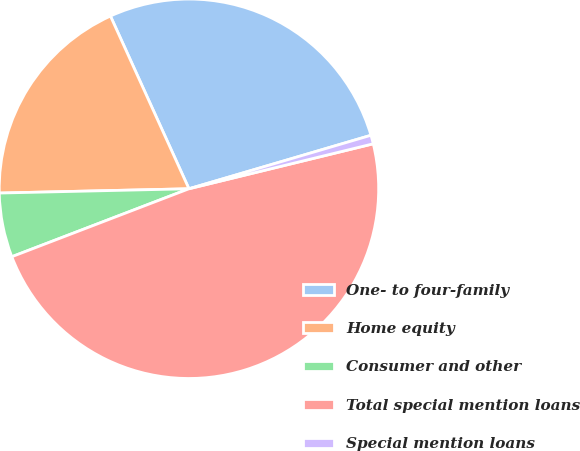Convert chart to OTSL. <chart><loc_0><loc_0><loc_500><loc_500><pie_chart><fcel>One- to four-family<fcel>Home equity<fcel>Consumer and other<fcel>Total special mention loans<fcel>Special mention loans<nl><fcel>27.24%<fcel>18.57%<fcel>5.47%<fcel>47.98%<fcel>0.74%<nl></chart> 